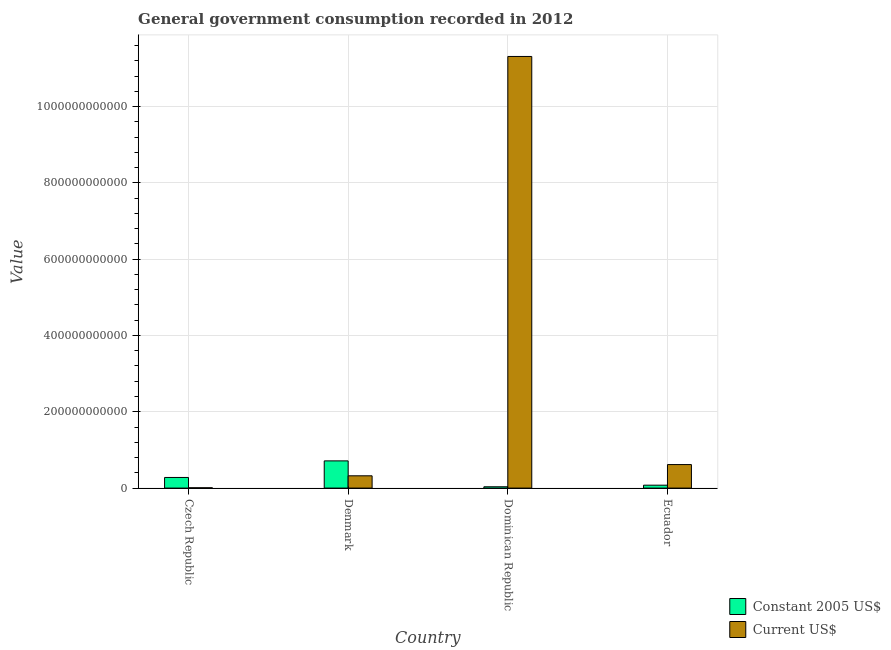What is the value consumed in current us$ in Denmark?
Give a very brief answer. 3.22e+1. Across all countries, what is the maximum value consumed in current us$?
Provide a short and direct response. 1.13e+12. Across all countries, what is the minimum value consumed in constant 2005 us$?
Ensure brevity in your answer.  3.45e+09. In which country was the value consumed in constant 2005 us$ maximum?
Provide a succinct answer. Denmark. In which country was the value consumed in constant 2005 us$ minimum?
Your answer should be very brief. Dominican Republic. What is the total value consumed in current us$ in the graph?
Provide a short and direct response. 1.23e+12. What is the difference between the value consumed in constant 2005 us$ in Denmark and that in Dominican Republic?
Your answer should be very brief. 6.78e+1. What is the difference between the value consumed in current us$ in Ecuador and the value consumed in constant 2005 us$ in Czech Republic?
Keep it short and to the point. 3.38e+1. What is the average value consumed in constant 2005 us$ per country?
Your answer should be compact. 2.76e+1. What is the difference between the value consumed in constant 2005 us$ and value consumed in current us$ in Dominican Republic?
Your answer should be compact. -1.13e+12. In how many countries, is the value consumed in current us$ greater than 160000000000 ?
Offer a very short reply. 1. What is the ratio of the value consumed in current us$ in Dominican Republic to that in Ecuador?
Ensure brevity in your answer.  18.35. Is the value consumed in current us$ in Czech Republic less than that in Ecuador?
Make the answer very short. Yes. What is the difference between the highest and the second highest value consumed in current us$?
Your response must be concise. 1.07e+12. What is the difference between the highest and the lowest value consumed in current us$?
Offer a very short reply. 1.13e+12. What does the 1st bar from the left in Denmark represents?
Offer a very short reply. Constant 2005 US$. What does the 2nd bar from the right in Dominican Republic represents?
Offer a terse response. Constant 2005 US$. How many countries are there in the graph?
Keep it short and to the point. 4. What is the difference between two consecutive major ticks on the Y-axis?
Offer a terse response. 2.00e+11. Are the values on the major ticks of Y-axis written in scientific E-notation?
Give a very brief answer. No. Where does the legend appear in the graph?
Make the answer very short. Bottom right. How are the legend labels stacked?
Make the answer very short. Vertical. What is the title of the graph?
Your answer should be compact. General government consumption recorded in 2012. Does "Foreign Liabilities" appear as one of the legend labels in the graph?
Keep it short and to the point. No. What is the label or title of the X-axis?
Your answer should be compact. Country. What is the label or title of the Y-axis?
Your response must be concise. Value. What is the Value of Constant 2005 US$ in Czech Republic?
Provide a short and direct response. 2.78e+1. What is the Value in Current US$ in Czech Republic?
Provide a short and direct response. 8.50e+08. What is the Value in Constant 2005 US$ in Denmark?
Your answer should be very brief. 7.13e+1. What is the Value of Current US$ in Denmark?
Keep it short and to the point. 3.22e+1. What is the Value of Constant 2005 US$ in Dominican Republic?
Offer a terse response. 3.45e+09. What is the Value of Current US$ in Dominican Republic?
Your answer should be very brief. 1.13e+12. What is the Value in Constant 2005 US$ in Ecuador?
Keep it short and to the point. 7.63e+09. What is the Value in Current US$ in Ecuador?
Give a very brief answer. 6.16e+1. Across all countries, what is the maximum Value in Constant 2005 US$?
Offer a very short reply. 7.13e+1. Across all countries, what is the maximum Value of Current US$?
Your answer should be compact. 1.13e+12. Across all countries, what is the minimum Value of Constant 2005 US$?
Keep it short and to the point. 3.45e+09. Across all countries, what is the minimum Value of Current US$?
Provide a short and direct response. 8.50e+08. What is the total Value of Constant 2005 US$ in the graph?
Offer a terse response. 1.10e+11. What is the total Value in Current US$ in the graph?
Provide a short and direct response. 1.23e+12. What is the difference between the Value in Constant 2005 US$ in Czech Republic and that in Denmark?
Your answer should be compact. -4.35e+1. What is the difference between the Value in Current US$ in Czech Republic and that in Denmark?
Your answer should be compact. -3.14e+1. What is the difference between the Value in Constant 2005 US$ in Czech Republic and that in Dominican Republic?
Your answer should be compact. 2.44e+1. What is the difference between the Value in Current US$ in Czech Republic and that in Dominican Republic?
Provide a succinct answer. -1.13e+12. What is the difference between the Value in Constant 2005 US$ in Czech Republic and that in Ecuador?
Your answer should be compact. 2.02e+1. What is the difference between the Value in Current US$ in Czech Republic and that in Ecuador?
Your answer should be very brief. -6.08e+1. What is the difference between the Value of Constant 2005 US$ in Denmark and that in Dominican Republic?
Your answer should be compact. 6.78e+1. What is the difference between the Value of Current US$ in Denmark and that in Dominican Republic?
Provide a short and direct response. -1.10e+12. What is the difference between the Value in Constant 2005 US$ in Denmark and that in Ecuador?
Provide a succinct answer. 6.37e+1. What is the difference between the Value of Current US$ in Denmark and that in Ecuador?
Make the answer very short. -2.94e+1. What is the difference between the Value of Constant 2005 US$ in Dominican Republic and that in Ecuador?
Your answer should be compact. -4.17e+09. What is the difference between the Value of Current US$ in Dominican Republic and that in Ecuador?
Your answer should be very brief. 1.07e+12. What is the difference between the Value of Constant 2005 US$ in Czech Republic and the Value of Current US$ in Denmark?
Your answer should be compact. -4.37e+09. What is the difference between the Value of Constant 2005 US$ in Czech Republic and the Value of Current US$ in Dominican Republic?
Give a very brief answer. -1.10e+12. What is the difference between the Value of Constant 2005 US$ in Czech Republic and the Value of Current US$ in Ecuador?
Ensure brevity in your answer.  -3.38e+1. What is the difference between the Value in Constant 2005 US$ in Denmark and the Value in Current US$ in Dominican Republic?
Provide a short and direct response. -1.06e+12. What is the difference between the Value of Constant 2005 US$ in Denmark and the Value of Current US$ in Ecuador?
Your answer should be very brief. 9.66e+09. What is the difference between the Value of Constant 2005 US$ in Dominican Republic and the Value of Current US$ in Ecuador?
Keep it short and to the point. -5.82e+1. What is the average Value of Constant 2005 US$ per country?
Your answer should be very brief. 2.76e+1. What is the average Value of Current US$ per country?
Your answer should be compact. 3.06e+11. What is the difference between the Value of Constant 2005 US$ and Value of Current US$ in Czech Republic?
Provide a short and direct response. 2.70e+1. What is the difference between the Value in Constant 2005 US$ and Value in Current US$ in Denmark?
Offer a very short reply. 3.91e+1. What is the difference between the Value of Constant 2005 US$ and Value of Current US$ in Dominican Republic?
Keep it short and to the point. -1.13e+12. What is the difference between the Value of Constant 2005 US$ and Value of Current US$ in Ecuador?
Your answer should be very brief. -5.40e+1. What is the ratio of the Value of Constant 2005 US$ in Czech Republic to that in Denmark?
Provide a short and direct response. 0.39. What is the ratio of the Value of Current US$ in Czech Republic to that in Denmark?
Your answer should be very brief. 0.03. What is the ratio of the Value of Constant 2005 US$ in Czech Republic to that in Dominican Republic?
Give a very brief answer. 8.06. What is the ratio of the Value in Current US$ in Czech Republic to that in Dominican Republic?
Make the answer very short. 0. What is the ratio of the Value of Constant 2005 US$ in Czech Republic to that in Ecuador?
Offer a terse response. 3.65. What is the ratio of the Value of Current US$ in Czech Republic to that in Ecuador?
Give a very brief answer. 0.01. What is the ratio of the Value of Constant 2005 US$ in Denmark to that in Dominican Republic?
Your response must be concise. 20.64. What is the ratio of the Value in Current US$ in Denmark to that in Dominican Republic?
Your response must be concise. 0.03. What is the ratio of the Value in Constant 2005 US$ in Denmark to that in Ecuador?
Provide a succinct answer. 9.35. What is the ratio of the Value of Current US$ in Denmark to that in Ecuador?
Make the answer very short. 0.52. What is the ratio of the Value in Constant 2005 US$ in Dominican Republic to that in Ecuador?
Make the answer very short. 0.45. What is the ratio of the Value in Current US$ in Dominican Republic to that in Ecuador?
Offer a very short reply. 18.35. What is the difference between the highest and the second highest Value in Constant 2005 US$?
Give a very brief answer. 4.35e+1. What is the difference between the highest and the second highest Value of Current US$?
Your response must be concise. 1.07e+12. What is the difference between the highest and the lowest Value of Constant 2005 US$?
Keep it short and to the point. 6.78e+1. What is the difference between the highest and the lowest Value of Current US$?
Provide a succinct answer. 1.13e+12. 